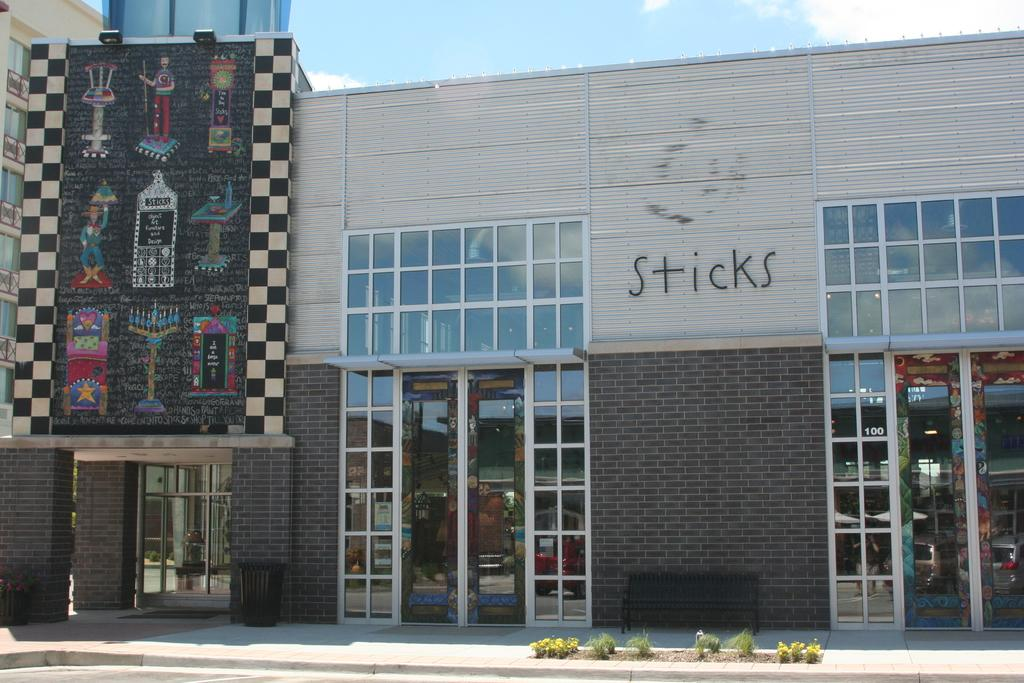<image>
Provide a brief description of the given image. The word sticks appears on a building with large glass doors and windows. 